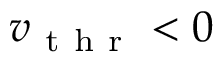<formula> <loc_0><loc_0><loc_500><loc_500>v _ { t h r } < 0</formula> 